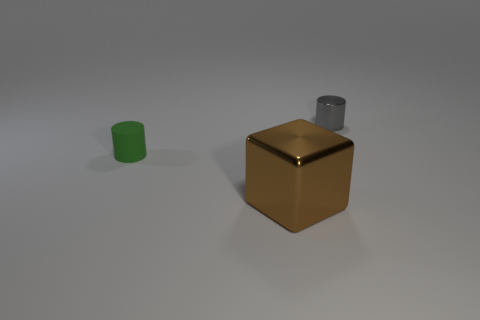Is there a green rubber thing that has the same size as the cube?
Give a very brief answer. No. There is a cylinder on the left side of the gray shiny cylinder; does it have the same size as the gray object?
Ensure brevity in your answer.  Yes. There is a thing that is to the right of the small matte thing and behind the brown metal thing; what is its shape?
Ensure brevity in your answer.  Cylinder. Are there more green objects that are left of the small green rubber cylinder than large objects?
Your response must be concise. No. What size is the block that is the same material as the gray object?
Provide a short and direct response. Large. How many tiny shiny objects have the same color as the large thing?
Your response must be concise. 0. There is a cylinder to the left of the small metallic object; does it have the same color as the metal cylinder?
Your answer should be very brief. No. Is the number of metal cubes that are left of the large brown block the same as the number of gray objects on the right side of the gray object?
Provide a short and direct response. Yes. Are there any other things that have the same material as the brown cube?
Make the answer very short. Yes. There is a metallic thing that is to the right of the big object; what is its color?
Your response must be concise. Gray. 